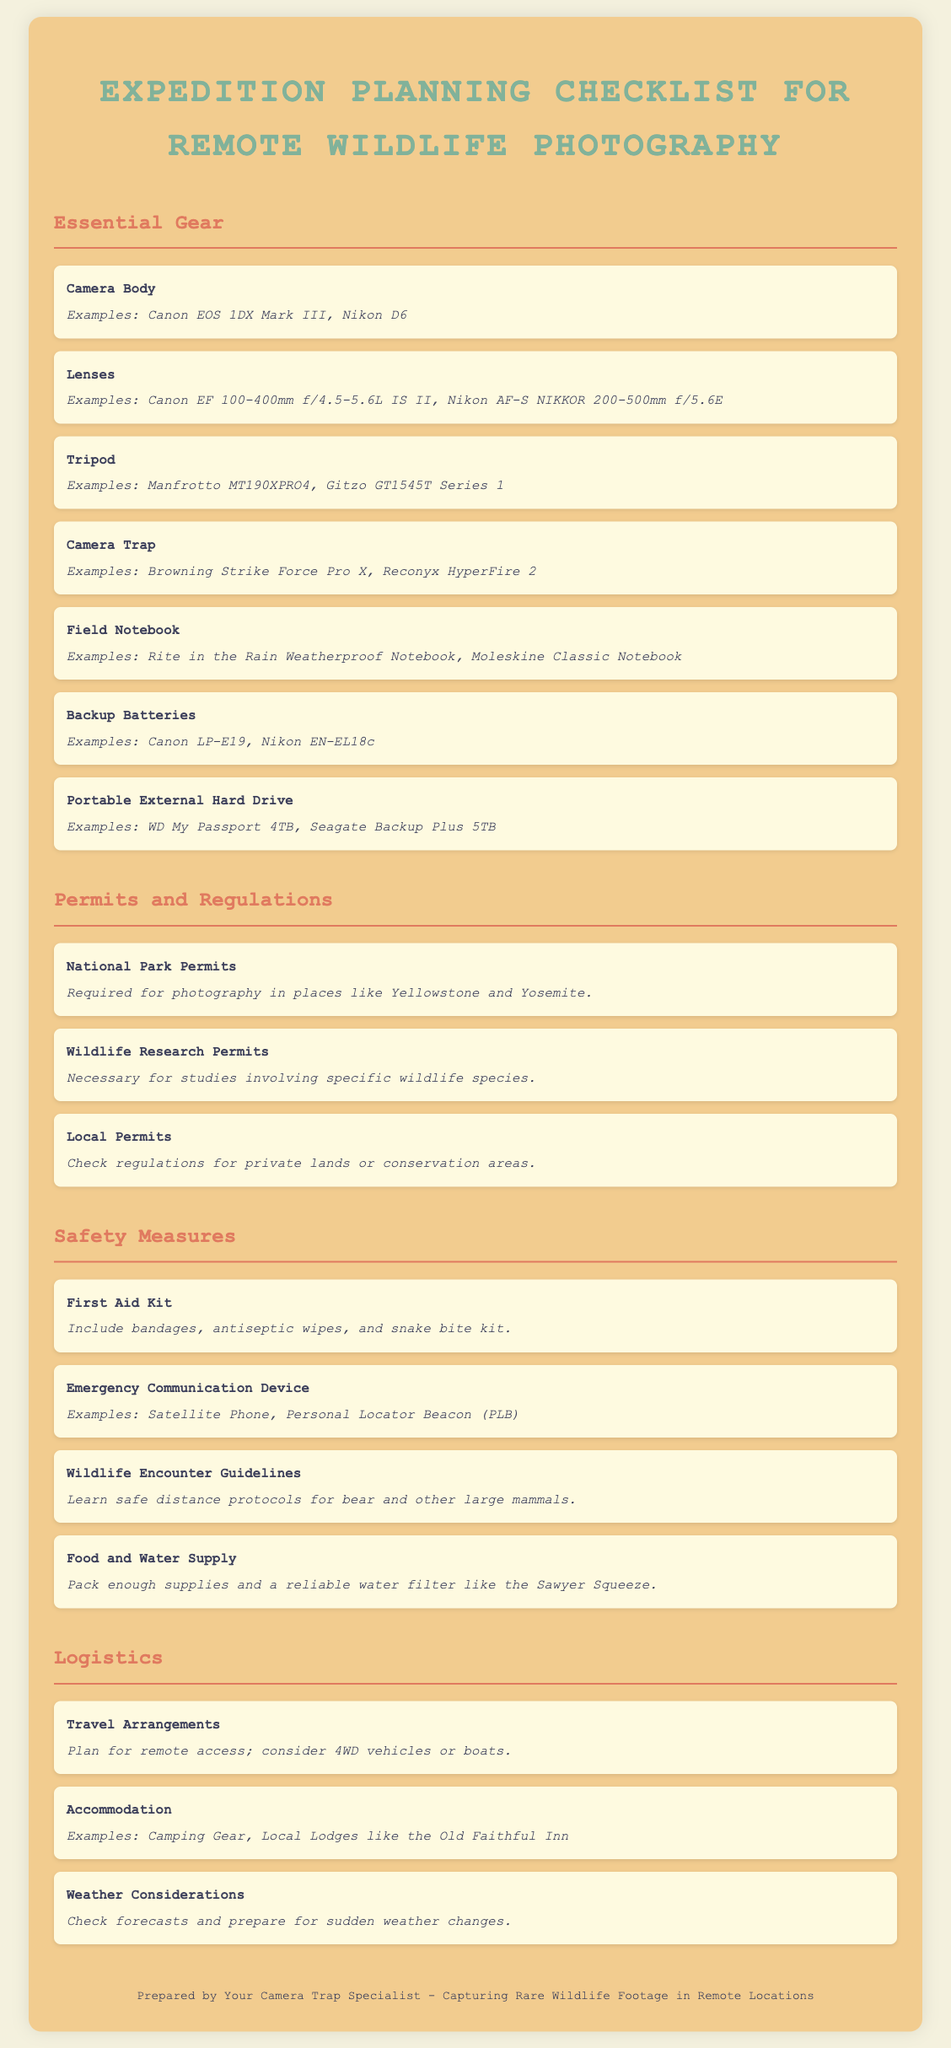What is one example of a camera body listed? The document provides specific examples of camera bodies to consider, such as the Canon EOS 1DX Mark III.
Answer: Canon EOS 1DX Mark III What type of permits are necessary for studies involving specific wildlife species? The document specifies that Wildlife Research Permits are necessary for certain studies.
Answer: Wildlife Research Permits What should be included in a first aid kit? The document mentions that a first aid kit should include bandages, antiseptic wipes, and a snake bite kit.
Answer: Bandages, antiseptic wipes, and snake bite kit Why is a portable external hard drive important? The document states that a portable external hard drive is essential for storing captured footage and images.
Answer: Storing captured footage and images Which accommodation option is mentioned alongside camping gear? The document lists example accommodation options for remote trips, including local lodges.
Answer: Local Lodges What device can be used for emergency communication? The document lists examples of an Emergency Communication Device, including a Satellite Phone.
Answer: Satellite Phone What is a crucial guideline to follow when encountering wildlife? The document emphasizes the importance of learning safe distance protocols for large mammals.
Answer: Safe distance protocols How should travel arrangements be planned according to the document? It suggests planning for remote access, considering 4WD vehicles or boats as crucial logistics.
Answer: 4WD vehicles or boats 